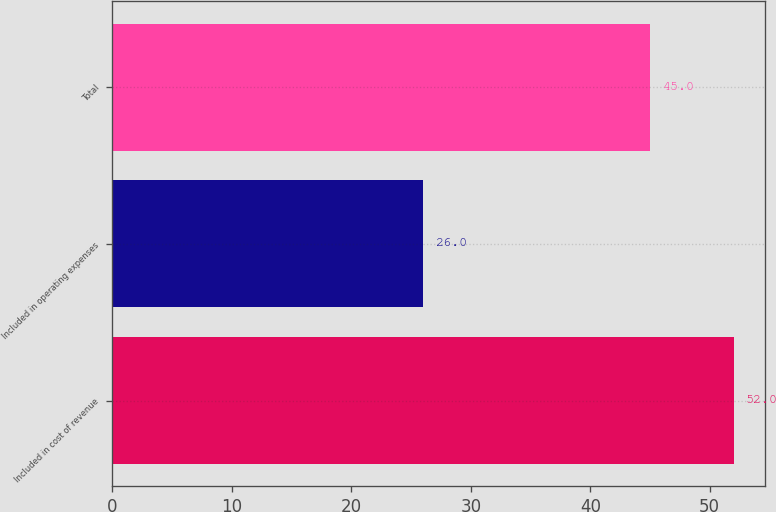<chart> <loc_0><loc_0><loc_500><loc_500><bar_chart><fcel>Included in cost of revenue<fcel>Included in operating expenses<fcel>Total<nl><fcel>52<fcel>26<fcel>45<nl></chart> 